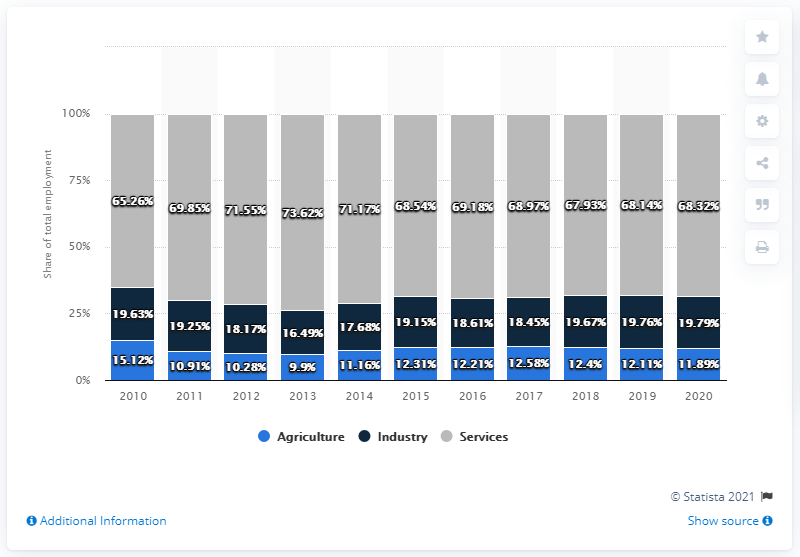Give some essential details in this illustration. The services sector has the highest employment, which makes it a leading source of job opportunities in the economy. The highest and smallest industry sector differ in terms of their scale and scope of operations. 